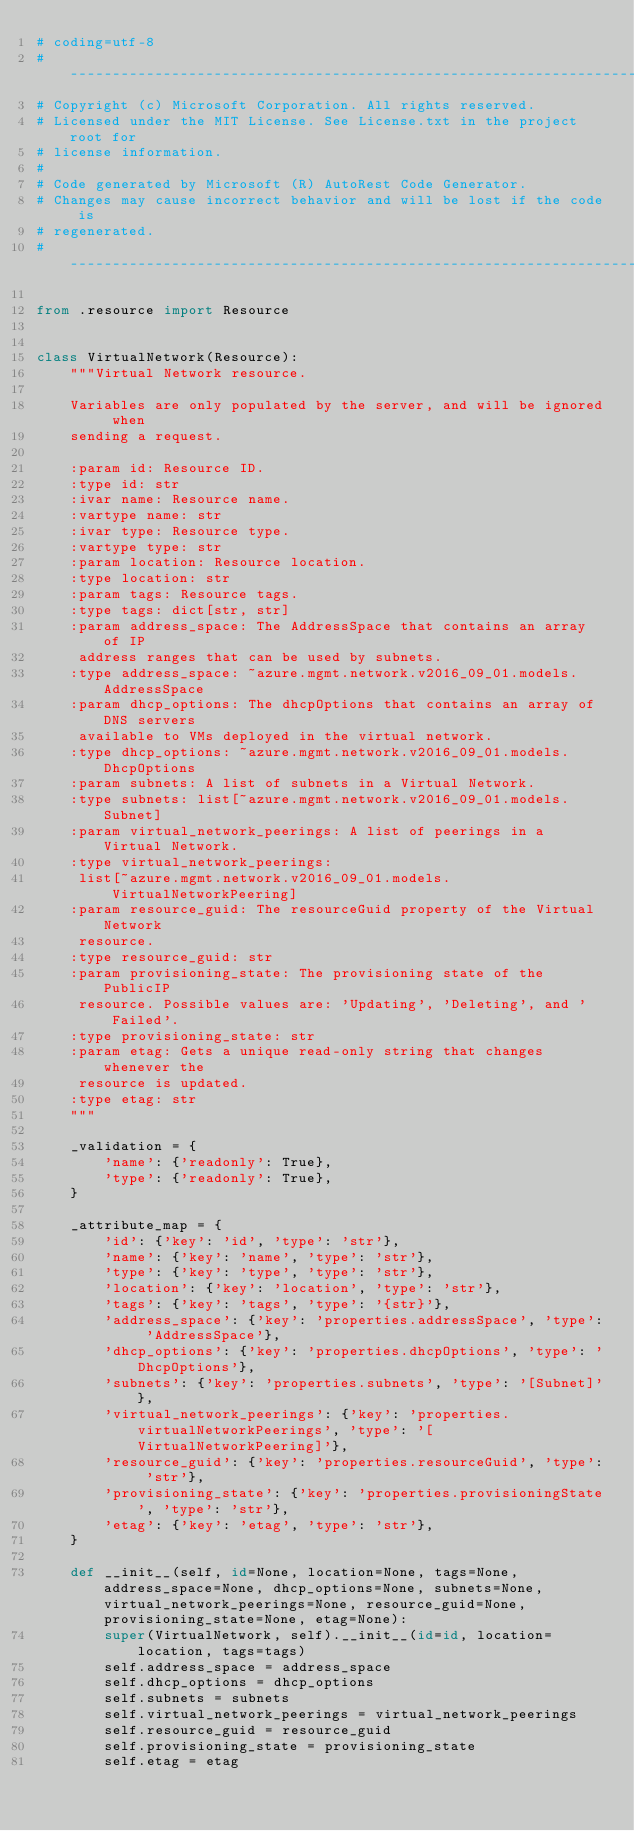Convert code to text. <code><loc_0><loc_0><loc_500><loc_500><_Python_># coding=utf-8
# --------------------------------------------------------------------------
# Copyright (c) Microsoft Corporation. All rights reserved.
# Licensed under the MIT License. See License.txt in the project root for
# license information.
#
# Code generated by Microsoft (R) AutoRest Code Generator.
# Changes may cause incorrect behavior and will be lost if the code is
# regenerated.
# --------------------------------------------------------------------------

from .resource import Resource


class VirtualNetwork(Resource):
    """Virtual Network resource.

    Variables are only populated by the server, and will be ignored when
    sending a request.

    :param id: Resource ID.
    :type id: str
    :ivar name: Resource name.
    :vartype name: str
    :ivar type: Resource type.
    :vartype type: str
    :param location: Resource location.
    :type location: str
    :param tags: Resource tags.
    :type tags: dict[str, str]
    :param address_space: The AddressSpace that contains an array of IP
     address ranges that can be used by subnets.
    :type address_space: ~azure.mgmt.network.v2016_09_01.models.AddressSpace
    :param dhcp_options: The dhcpOptions that contains an array of DNS servers
     available to VMs deployed in the virtual network.
    :type dhcp_options: ~azure.mgmt.network.v2016_09_01.models.DhcpOptions
    :param subnets: A list of subnets in a Virtual Network.
    :type subnets: list[~azure.mgmt.network.v2016_09_01.models.Subnet]
    :param virtual_network_peerings: A list of peerings in a Virtual Network.
    :type virtual_network_peerings:
     list[~azure.mgmt.network.v2016_09_01.models.VirtualNetworkPeering]
    :param resource_guid: The resourceGuid property of the Virtual Network
     resource.
    :type resource_guid: str
    :param provisioning_state: The provisioning state of the PublicIP
     resource. Possible values are: 'Updating', 'Deleting', and 'Failed'.
    :type provisioning_state: str
    :param etag: Gets a unique read-only string that changes whenever the
     resource is updated.
    :type etag: str
    """

    _validation = {
        'name': {'readonly': True},
        'type': {'readonly': True},
    }

    _attribute_map = {
        'id': {'key': 'id', 'type': 'str'},
        'name': {'key': 'name', 'type': 'str'},
        'type': {'key': 'type', 'type': 'str'},
        'location': {'key': 'location', 'type': 'str'},
        'tags': {'key': 'tags', 'type': '{str}'},
        'address_space': {'key': 'properties.addressSpace', 'type': 'AddressSpace'},
        'dhcp_options': {'key': 'properties.dhcpOptions', 'type': 'DhcpOptions'},
        'subnets': {'key': 'properties.subnets', 'type': '[Subnet]'},
        'virtual_network_peerings': {'key': 'properties.virtualNetworkPeerings', 'type': '[VirtualNetworkPeering]'},
        'resource_guid': {'key': 'properties.resourceGuid', 'type': 'str'},
        'provisioning_state': {'key': 'properties.provisioningState', 'type': 'str'},
        'etag': {'key': 'etag', 'type': 'str'},
    }

    def __init__(self, id=None, location=None, tags=None, address_space=None, dhcp_options=None, subnets=None, virtual_network_peerings=None, resource_guid=None, provisioning_state=None, etag=None):
        super(VirtualNetwork, self).__init__(id=id, location=location, tags=tags)
        self.address_space = address_space
        self.dhcp_options = dhcp_options
        self.subnets = subnets
        self.virtual_network_peerings = virtual_network_peerings
        self.resource_guid = resource_guid
        self.provisioning_state = provisioning_state
        self.etag = etag
</code> 